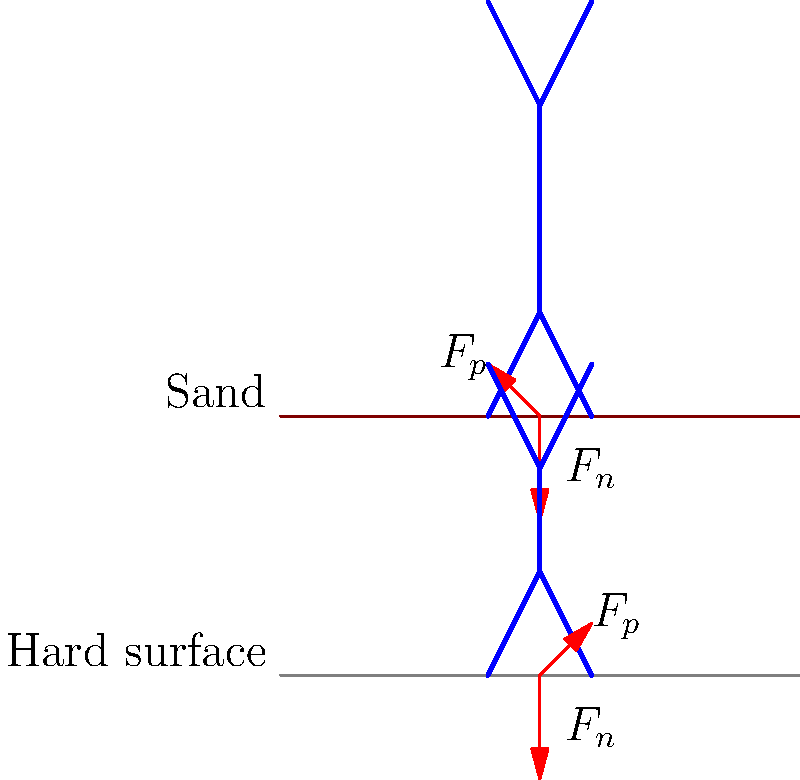As a former Baywatch enthusiast, you're familiar with running on the beach. Compare the biomechanics of running on sand to running on a hard surface. Which surface requires more energy expenditure and why? To understand the biomechanics of running on sand versus a hard surface, let's break it down step-by-step:

1. Force distribution:
   - On sand: The foot sinks into the sand, increasing the surface area of contact.
   - On hard surface: The foot strikes a solid, non-deformable surface.

2. Ground reaction forces:
   - On sand: The normal force ($F_n$) is smaller due to the give in the sand.
   - On hard surface: The normal force ($F_n$) is larger and more immediate.

3. Propulsive forces:
   - On sand: The propulsive force ($F_p$) is reduced due to energy absorption by the sand.
   - On hard surface: The propulsive force ($F_p$) is more efficient, with less energy loss.

4. Muscle activation:
   - On sand: More muscles are engaged to stabilize the foot and ankle.
   - On hard surface: Fewer stabilizing muscles are required.

5. Energy return:
   - On sand: Minimal energy return from the surface.
   - On hard surface: Some energy return from the elastic recoil of the surface.

6. Stride length and frequency:
   - On sand: Shorter stride length and potentially higher stride frequency.
   - On hard surface: Longer stride length and typically lower stride frequency.

7. Joint angles:
   - On sand: Greater ankle dorsiflexion and knee flexion at foot strike.
   - On hard surface: Less extreme joint angles at foot strike.

8. Energy expenditure:
   - On sand: Higher energy expenditure due to increased muscle activation and reduced efficiency.
   - On hard surface: Lower energy expenditure due to more efficient force transfer and energy return.

The biomechanics of running on sand require more energy expenditure primarily due to the instability of the surface, increased muscle activation for stabilization, and reduced efficiency in force transfer and energy return.
Answer: Running on sand requires more energy expenditure due to surface instability, increased muscle activation, and reduced force transfer efficiency. 